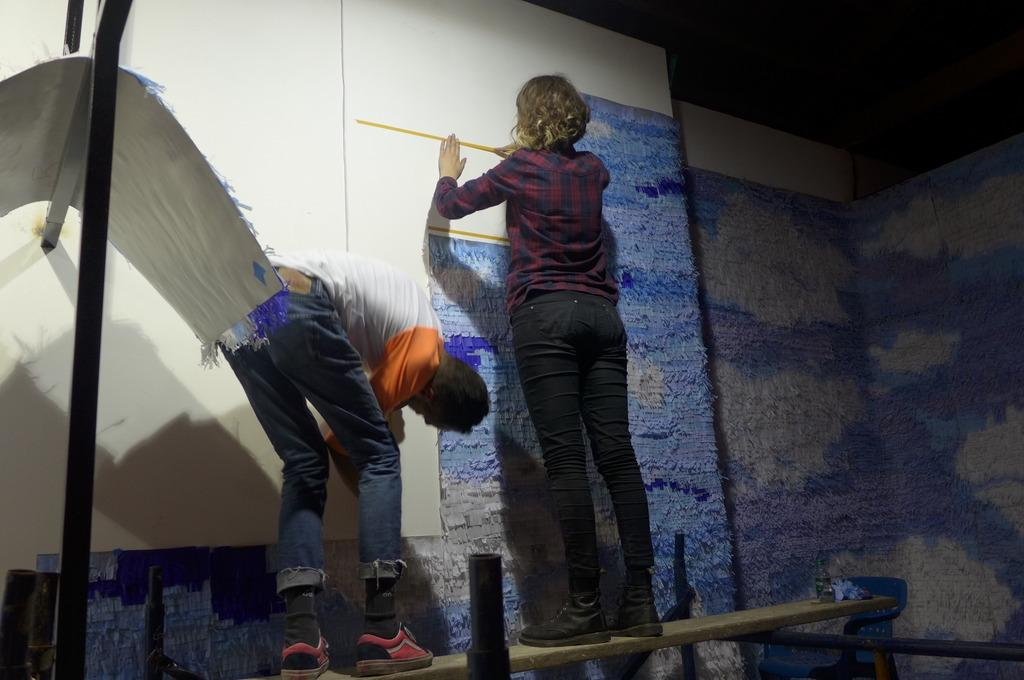Who are the people in the image? There is a man and a woman in the image. What are the man and woman doing in the image? The man is holding a board, and the woman is using a tape measure. What are they standing on in the image? They are standing on a wooden plank. How many bees can be seen buzzing around the edge of the wooden plank in the image? There are no bees present in the image. 